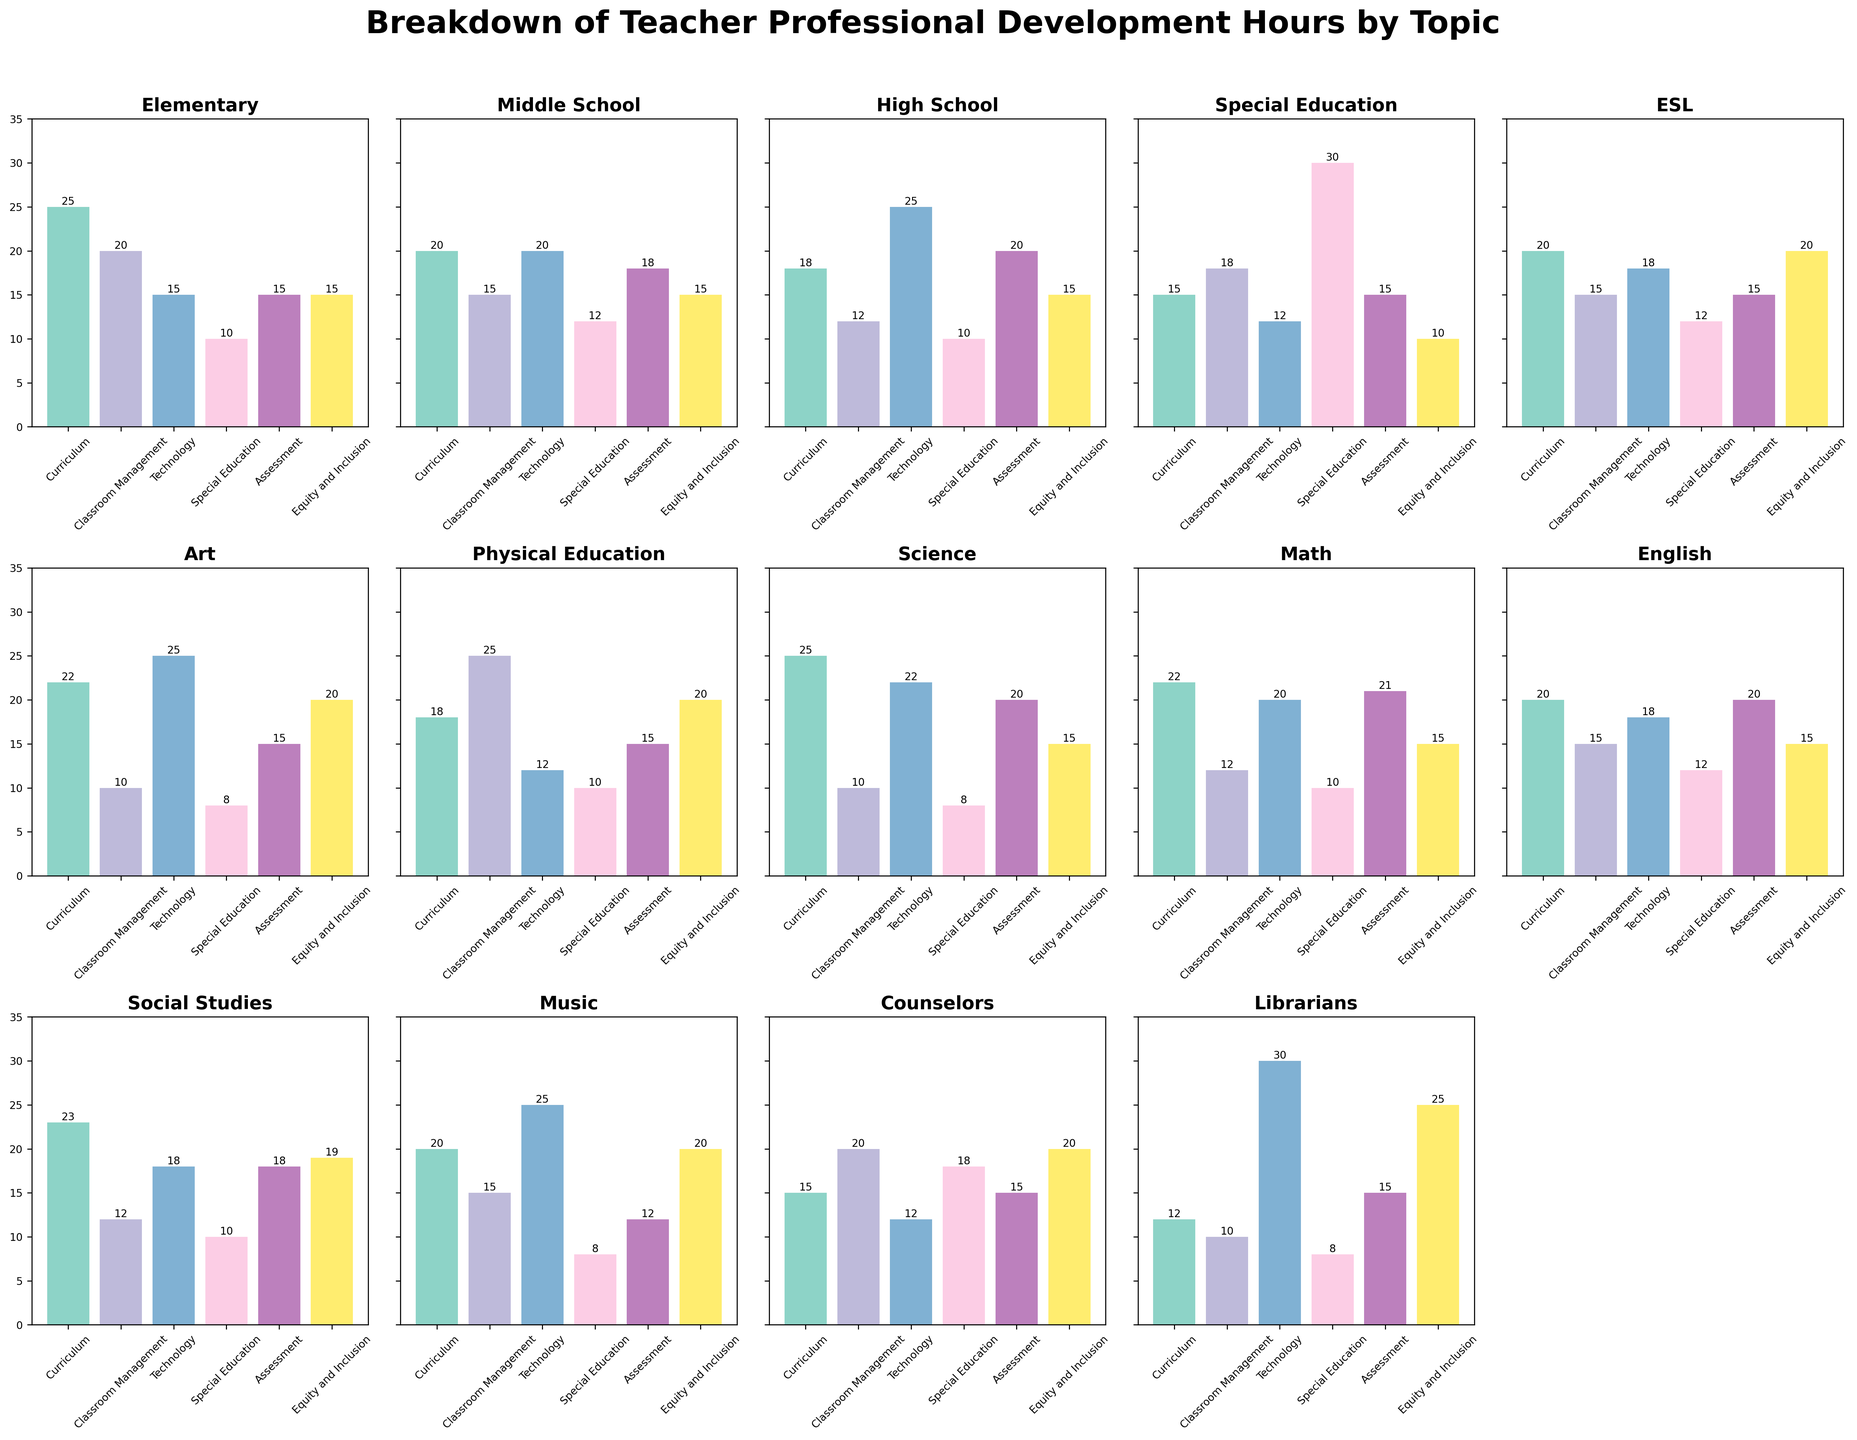What is the total number of professional development hours for Special Education teachers in Technology and Classroom Management? Add the number of hours for Technology (12) and Classroom Management (18) for Special Education teachers. 12 + 18 = 30
Answer: 30 Which topic has the highest number of professional development hours for Elementary teachers? Look at the bar heights for Elementary teachers and identify the tallest one, which corresponds to Curriculum (25)
Answer: Curriculum How many professional development hours does the Math group have in Assessment and Special Education combined? Check the bar heights for Math in Assessment (21) and Special Education (10), then add them together. 21 + 10 = 31
Answer: 31 Which teacher type spends the least amount of time on Special Education training? Find the shortest bar in the Special Education topic across all teacher types, which is Art and Music teachers (8 hours each)
Answer: Art and Music What is the average number of professional development hours in Technology across all teacher types? Sum all the values for Technology and divide by the number of teacher types. (15+20+25+12+18+25+12+22+20+18+18+25+12+30)/14. The total is 272, so 272/14 ≈ 19.4
Answer: 19.4 Which teacher type has the highest total number of professional development hours across all topics? Calculate the total for each teacher type and compare. For example, for Elementary: 25+20+15+10+15+15 = 100. Highest total is Librarians (12+10+30+8+15+25 = 100)
Answer: Elementary and Librarians Between Assessment and Curriculum, which topic has more professional development hours for High School teachers? Compare the heights of the bars for Assessment (20) and Curriculum (18) for High School teachers. Assessment is higher
Answer: Assessment What is the difference in total professional development hours between Social Studies and Physical Education teachers? Sum the hours for Social Studies (23+12+18+10+18+19 = 100) and Physical Education (18+25+12+10+15+20 = 100), then find the difference. The difference is 100 - 100 = 0
Answer: 0 Which two topics are tied for the lowest number of hours for physical education teachers, and how many hours are spent on each? Identify the two shortest bars for Physical Education, which are Special Education (10) and Assessment (10)
Answer: Special Education and Assessment, 10 hours each What is the median number of professional development hours for English teachers across all topics? List the values for English (20, 15, 18, 12, 20, 15) in ascending order (12, 15, 15, 18, 20, 20). The median is the average of the two middle numbers, (15+18)/2 = 16.5
Answer: 16.5 